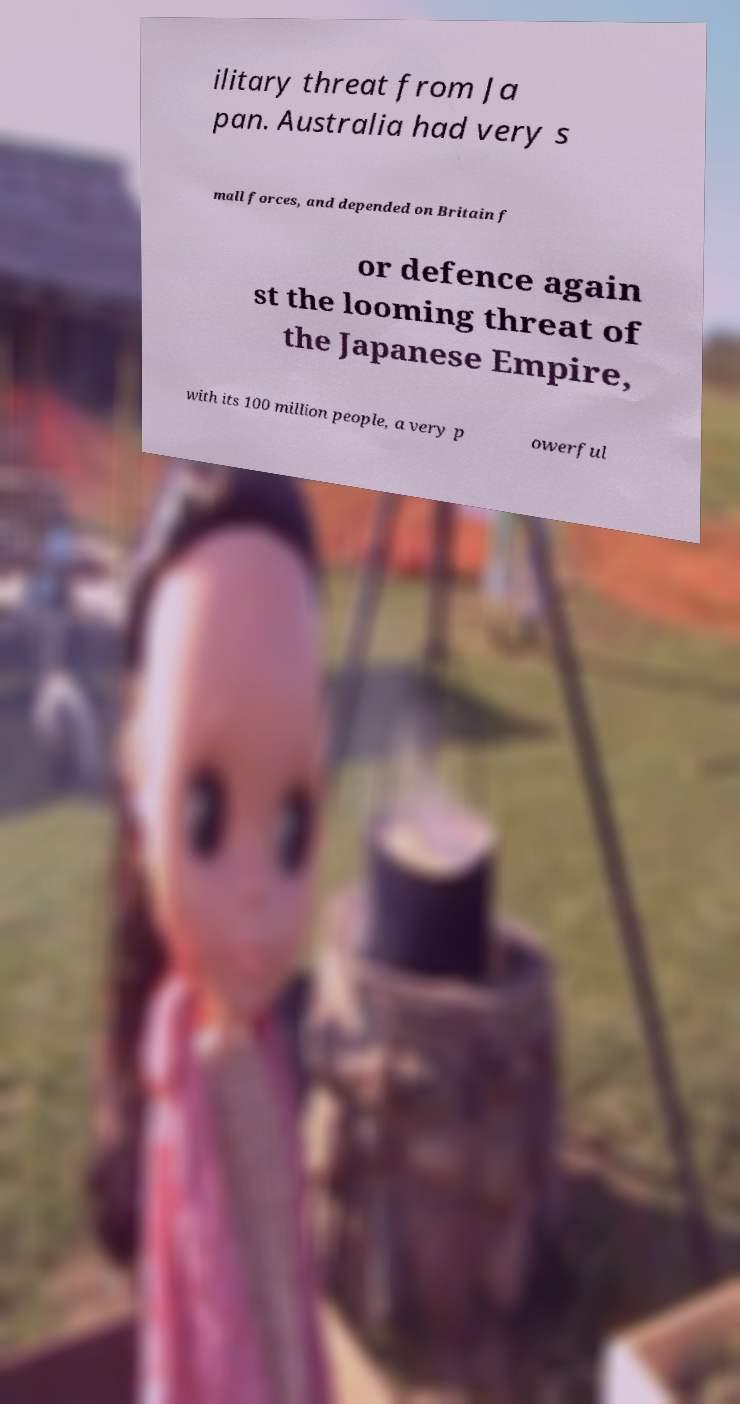What messages or text are displayed in this image? I need them in a readable, typed format. ilitary threat from Ja pan. Australia had very s mall forces, and depended on Britain f or defence again st the looming threat of the Japanese Empire, with its 100 million people, a very p owerful 